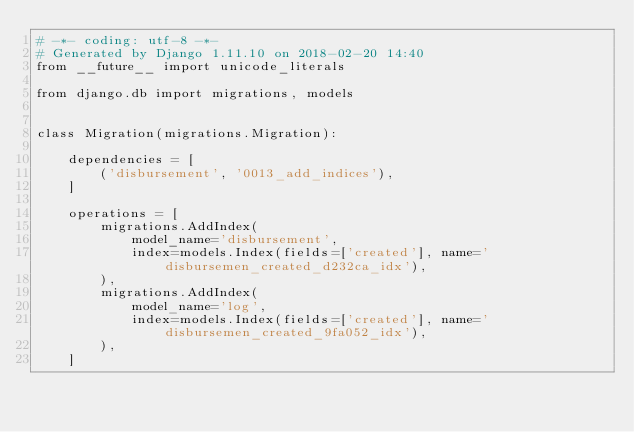Convert code to text. <code><loc_0><loc_0><loc_500><loc_500><_Python_># -*- coding: utf-8 -*-
# Generated by Django 1.11.10 on 2018-02-20 14:40
from __future__ import unicode_literals

from django.db import migrations, models


class Migration(migrations.Migration):

    dependencies = [
        ('disbursement', '0013_add_indices'),
    ]

    operations = [
        migrations.AddIndex(
            model_name='disbursement',
            index=models.Index(fields=['created'], name='disbursemen_created_d232ca_idx'),
        ),
        migrations.AddIndex(
            model_name='log',
            index=models.Index(fields=['created'], name='disbursemen_created_9fa052_idx'),
        ),
    ]
</code> 